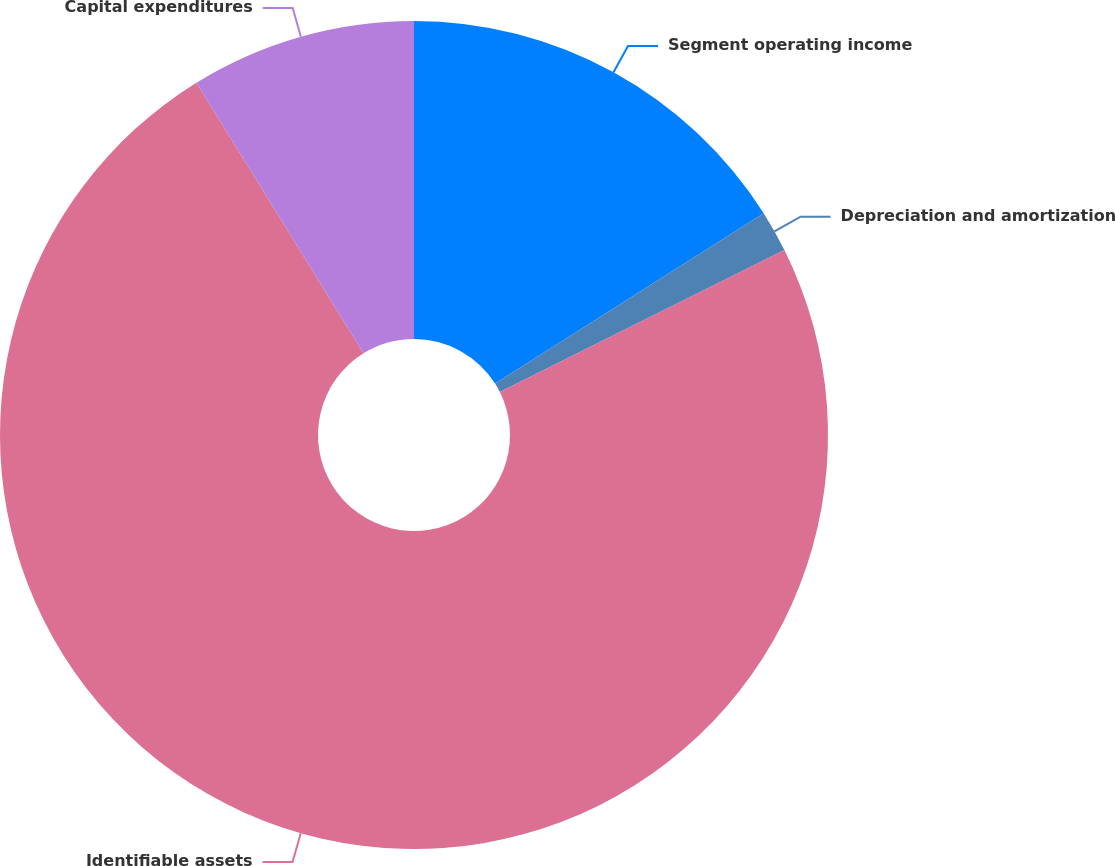<chart> <loc_0><loc_0><loc_500><loc_500><pie_chart><fcel>Segment operating income<fcel>Depreciation and amortization<fcel>Identifiable assets<fcel>Capital expenditures<nl><fcel>16.01%<fcel>1.62%<fcel>73.57%<fcel>8.81%<nl></chart> 